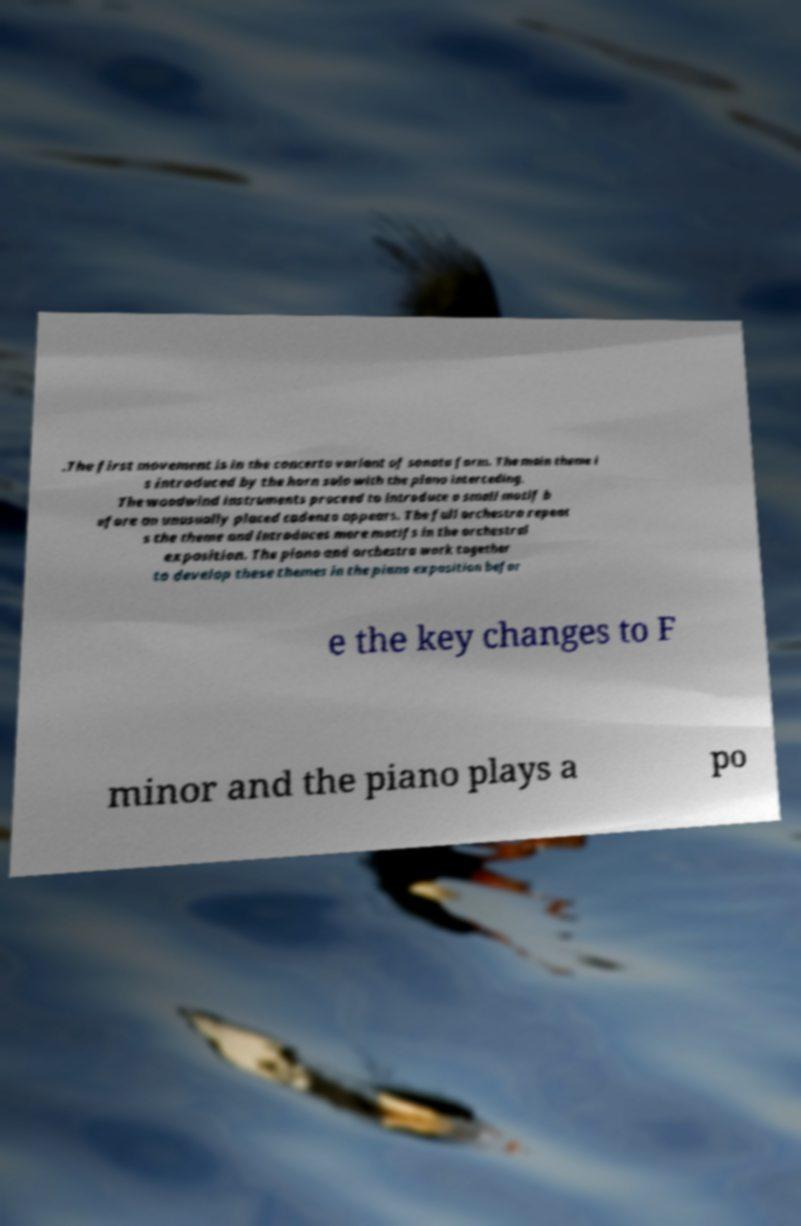For documentation purposes, I need the text within this image transcribed. Could you provide that? .The first movement is in the concerto variant of sonata form. The main theme i s introduced by the horn solo with the piano interceding. The woodwind instruments proceed to introduce a small motif b efore an unusually placed cadenza appears. The full orchestra repeat s the theme and introduces more motifs in the orchestral exposition. The piano and orchestra work together to develop these themes in the piano exposition befor e the key changes to F minor and the piano plays a po 